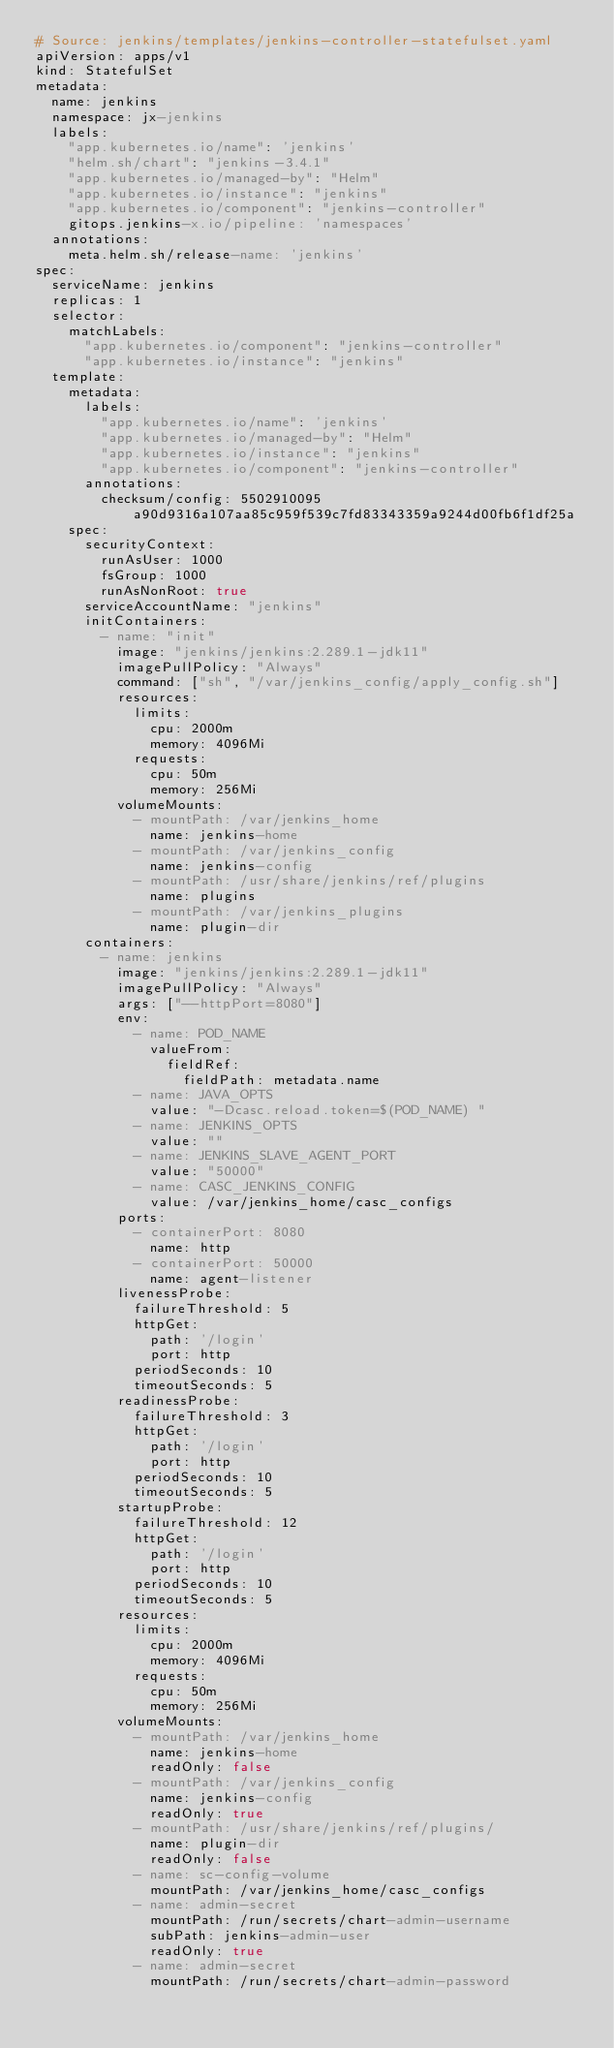<code> <loc_0><loc_0><loc_500><loc_500><_YAML_># Source: jenkins/templates/jenkins-controller-statefulset.yaml
apiVersion: apps/v1
kind: StatefulSet
metadata:
  name: jenkins
  namespace: jx-jenkins
  labels:
    "app.kubernetes.io/name": 'jenkins'
    "helm.sh/chart": "jenkins-3.4.1"
    "app.kubernetes.io/managed-by": "Helm"
    "app.kubernetes.io/instance": "jenkins"
    "app.kubernetes.io/component": "jenkins-controller"
    gitops.jenkins-x.io/pipeline: 'namespaces'
  annotations:
    meta.helm.sh/release-name: 'jenkins'
spec:
  serviceName: jenkins
  replicas: 1
  selector:
    matchLabels:
      "app.kubernetes.io/component": "jenkins-controller"
      "app.kubernetes.io/instance": "jenkins"
  template:
    metadata:
      labels:
        "app.kubernetes.io/name": 'jenkins'
        "app.kubernetes.io/managed-by": "Helm"
        "app.kubernetes.io/instance": "jenkins"
        "app.kubernetes.io/component": "jenkins-controller"
      annotations:
        checksum/config: 5502910095a90d9316a107aa85c959f539c7fd83343359a9244d00fb6f1df25a
    spec:
      securityContext:
        runAsUser: 1000
        fsGroup: 1000
        runAsNonRoot: true
      serviceAccountName: "jenkins"
      initContainers:
        - name: "init"
          image: "jenkins/jenkins:2.289.1-jdk11"
          imagePullPolicy: "Always"
          command: ["sh", "/var/jenkins_config/apply_config.sh"]
          resources:
            limits:
              cpu: 2000m
              memory: 4096Mi
            requests:
              cpu: 50m
              memory: 256Mi
          volumeMounts:
            - mountPath: /var/jenkins_home
              name: jenkins-home
            - mountPath: /var/jenkins_config
              name: jenkins-config
            - mountPath: /usr/share/jenkins/ref/plugins
              name: plugins
            - mountPath: /var/jenkins_plugins
              name: plugin-dir
      containers:
        - name: jenkins
          image: "jenkins/jenkins:2.289.1-jdk11"
          imagePullPolicy: "Always"
          args: ["--httpPort=8080"]
          env:
            - name: POD_NAME
              valueFrom:
                fieldRef:
                  fieldPath: metadata.name
            - name: JAVA_OPTS
              value: "-Dcasc.reload.token=$(POD_NAME) "
            - name: JENKINS_OPTS
              value: ""
            - name: JENKINS_SLAVE_AGENT_PORT
              value: "50000"
            - name: CASC_JENKINS_CONFIG
              value: /var/jenkins_home/casc_configs
          ports:
            - containerPort: 8080
              name: http
            - containerPort: 50000
              name: agent-listener
          livenessProbe:
            failureThreshold: 5
            httpGet:
              path: '/login'
              port: http
            periodSeconds: 10
            timeoutSeconds: 5
          readinessProbe:
            failureThreshold: 3
            httpGet:
              path: '/login'
              port: http
            periodSeconds: 10
            timeoutSeconds: 5
          startupProbe:
            failureThreshold: 12
            httpGet:
              path: '/login'
              port: http
            periodSeconds: 10
            timeoutSeconds: 5
          resources:
            limits:
              cpu: 2000m
              memory: 4096Mi
            requests:
              cpu: 50m
              memory: 256Mi
          volumeMounts:
            - mountPath: /var/jenkins_home
              name: jenkins-home
              readOnly: false
            - mountPath: /var/jenkins_config
              name: jenkins-config
              readOnly: true
            - mountPath: /usr/share/jenkins/ref/plugins/
              name: plugin-dir
              readOnly: false
            - name: sc-config-volume
              mountPath: /var/jenkins_home/casc_configs
            - name: admin-secret
              mountPath: /run/secrets/chart-admin-username
              subPath: jenkins-admin-user
              readOnly: true
            - name: admin-secret
              mountPath: /run/secrets/chart-admin-password</code> 